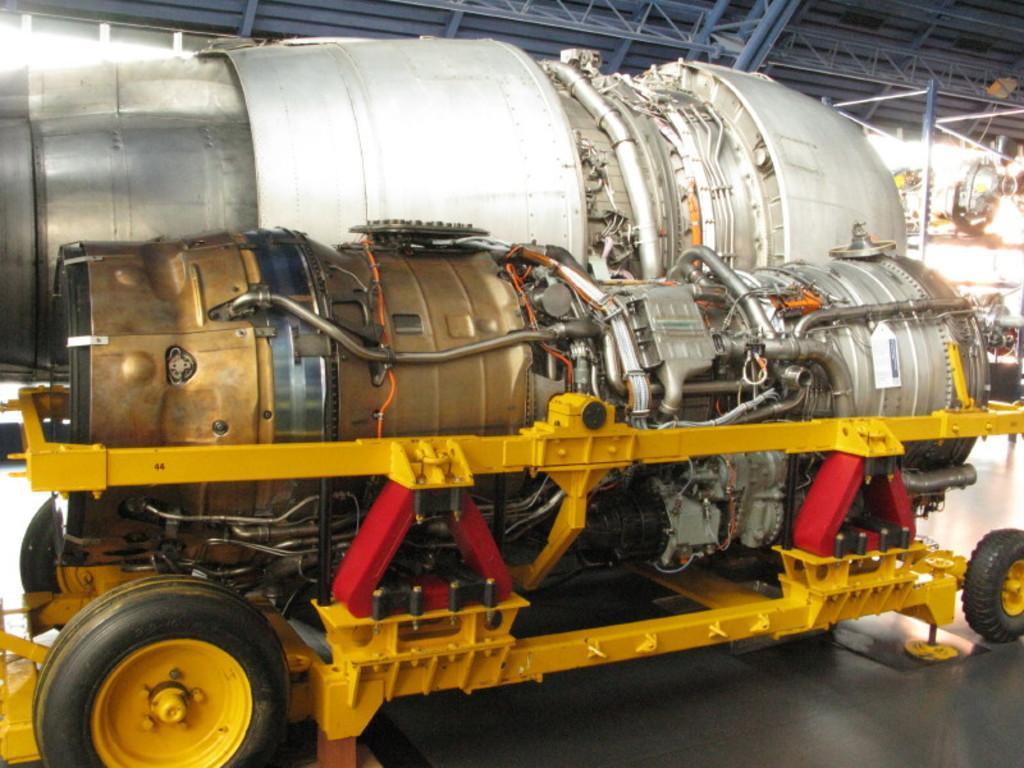Describe this image in one or two sentences. This image consists of some equipment like motors. There is some vehicle at the bottom. It has wheels. 